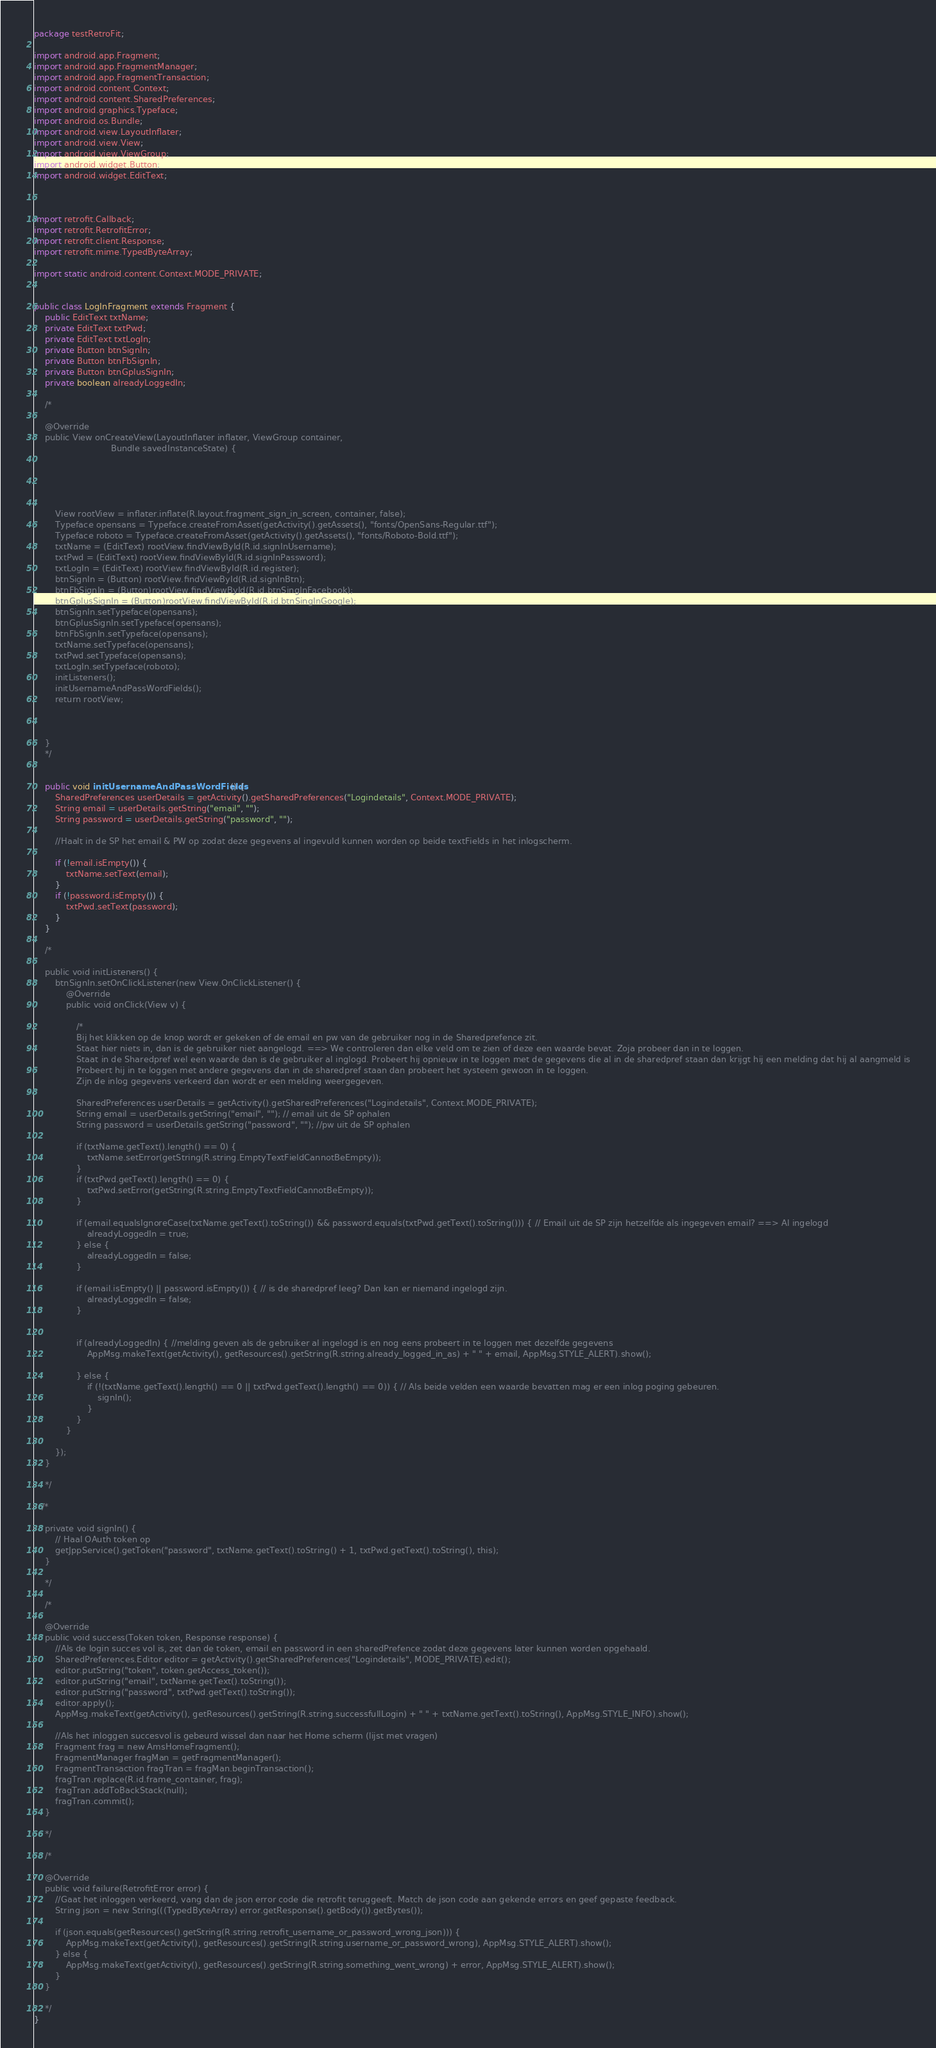<code> <loc_0><loc_0><loc_500><loc_500><_Java_>package testRetroFit;

import android.app.Fragment;
import android.app.FragmentManager;
import android.app.FragmentTransaction;
import android.content.Context;
import android.content.SharedPreferences;
import android.graphics.Typeface;
import android.os.Bundle;
import android.view.LayoutInflater;
import android.view.View;
import android.view.ViewGroup;
import android.widget.Button;
import android.widget.EditText;



import retrofit.Callback;
import retrofit.RetrofitError;
import retrofit.client.Response;
import retrofit.mime.TypedByteArray;

import static android.content.Context.MODE_PRIVATE;


public class LogInFragment extends Fragment {
    public EditText txtName;
    private EditText txtPwd;
    private EditText txtLogIn;
    private Button btnSignIn;
    private Button btnFbSignIn;
    private Button btnGplusSignIn;
    private boolean alreadyLoggedIn;

    /*

    @Override
    public View onCreateView(LayoutInflater inflater, ViewGroup container,
                             Bundle savedInstanceState) {





        View rootView = inflater.inflate(R.layout.fragment_sign_in_screen, container, false);
        Typeface opensans = Typeface.createFromAsset(getActivity().getAssets(), "fonts/OpenSans-Regular.ttf");
        Typeface roboto = Typeface.createFromAsset(getActivity().getAssets(), "fonts/Roboto-Bold.ttf");
        txtName = (EditText) rootView.findViewById(R.id.signInUsername);
        txtPwd = (EditText) rootView.findViewById(R.id.signInPassword);
        txtLogIn = (EditText) rootView.findViewById(R.id.register);
        btnSignIn = (Button) rootView.findViewById(R.id.signInBtn);
        btnFbSignIn = (Button)rootView.findViewById(R.id.btnSingInFacebook);
        btnGplusSignIn = (Button)rootView.findViewById(R.id.btnSingInGoogle);
        btnSignIn.setTypeface(opensans);
        btnGplusSignIn.setTypeface(opensans);
        btnFbSignIn.setTypeface(opensans);
        txtName.setTypeface(opensans);
        txtPwd.setTypeface(opensans);
        txtLogIn.setTypeface(roboto);
        initListeners();
        initUsernameAndPassWordFields();
        return rootView;



    }
    */


    public void initUsernameAndPassWordFields() {
        SharedPreferences userDetails = getActivity().getSharedPreferences("Logindetails", Context.MODE_PRIVATE);
        String email = userDetails.getString("email", "");
        String password = userDetails.getString("password", "");

        //Haalt in de SP het email & PW op zodat deze gegevens al ingevuld kunnen worden op beide textFields in het inlogscherm.

        if (!email.isEmpty()) {
            txtName.setText(email);
        }
        if (!password.isEmpty()) {
            txtPwd.setText(password);
        }
    }

    /*

    public void initListeners() {
        btnSignIn.setOnClickListener(new View.OnClickListener() {
            @Override
            public void onClick(View v) {

                /*
                Bij het klikken op de knop wordt er gekeken of de email en pw van de gebruiker nog in de Sharedprefence zit.
                Staat hier niets in, dan is de gebruiker niet aangelogd. ==> We controleren dan elke veld om te zien of deze een waarde bevat. Zoja probeer dan in te loggen.
                Staat in de Sharedpref wel een waarde dan is de gebruiker al inglogd. Probeert hij opnieuw in te loggen met de gegevens die al in de sharedpref staan dan krijgt hij een melding dat hij al aangmeld is
                Probeert hij in te loggen met andere gegevens dan in de sharedpref staan dan probeert het systeem gewoon in te loggen.
                Zijn de inlog gegevens verkeerd dan wordt er een melding weergegeven.

                SharedPreferences userDetails = getActivity().getSharedPreferences("Logindetails", Context.MODE_PRIVATE);
                String email = userDetails.getString("email", ""); // email uit de SP ophalen
                String password = userDetails.getString("password", ""); //pw uit de SP ophalen

                if (txtName.getText().length() == 0) {
                    txtName.setError(getString(R.string.EmptyTextFieldCannotBeEmpty));
                }
                if (txtPwd.getText().length() == 0) {
                    txtPwd.setError(getString(R.string.EmptyTextFieldCannotBeEmpty));
                }

                if (email.equalsIgnoreCase(txtName.getText().toString()) && password.equals(txtPwd.getText().toString())) { // Email uit de SP zijn hetzelfde als ingegeven email? ==> Al ingelogd
                    alreadyLoggedIn = true;
                } else {
                    alreadyLoggedIn = false;
                }

                if (email.isEmpty() || password.isEmpty()) { // is de sharedpref leeg? Dan kan er niemand ingelogd zijn.
                    alreadyLoggedIn = false;
                }


                if (alreadyLoggedIn) { //melding geven als de gebruiker al ingelogd is en nog eens probeert in te loggen met dezelfde gegevens
                    AppMsg.makeText(getActivity(), getResources().getString(R.string.already_logged_in_as) + " " + email, AppMsg.STYLE_ALERT).show();

                } else {
                    if (!(txtName.getText().length() == 0 || txtPwd.getText().length() == 0)) { // Als beide velden een waarde bevatten mag er een inlog poging gebeuren.
                        signIn();
                    }
                }
            }

        });
    }

    */

   /*

    private void signIn() {
        // Haal OAuth token op
        getJppService().getToken("password", txtName.getText().toString() + 1, txtPwd.getText().toString(), this);
    }

    */

    /*

    @Override
    public void success(Token token, Response response) {
        //Als de login succes vol is, zet dan de token, email en password in een sharedPrefence zodat deze gegevens later kunnen worden opgehaald.
        SharedPreferences.Editor editor = getActivity().getSharedPreferences("Logindetails", MODE_PRIVATE).edit();
        editor.putString("token", token.getAccess_token());
        editor.putString("email", txtName.getText().toString());
        editor.putString("password", txtPwd.getText().toString());
        editor.apply();
        AppMsg.makeText(getActivity(), getResources().getString(R.string.successfullLogin) + " " + txtName.getText().toString(), AppMsg.STYLE_INFO).show();

        //Als het inloggen succesvol is gebeurd wissel dan naar het Home scherm (lijst met vragen)
        Fragment frag = new AmsHomeFragment();
        FragmentManager fragMan = getFragmentManager();
        FragmentTransaction fragTran = fragMan.beginTransaction();
        fragTran.replace(R.id.frame_container, frag);
        fragTran.addToBackStack(null);
        fragTran.commit();
    }

    */

    /*

    @Override
    public void failure(RetrofitError error) {
        //Gaat het inloggen verkeerd, vang dan de json error code die retrofit teruggeeft. Match de json code aan gekende errors en geef gepaste feedback.
        String json = new String(((TypedByteArray) error.getResponse().getBody()).getBytes());

        if (json.equals(getResources().getString(R.string.retrofit_username_or_password_wrong_json))) {
            AppMsg.makeText(getActivity(), getResources().getString(R.string.username_or_password_wrong), AppMsg.STYLE_ALERT).show();
        } else {
            AppMsg.makeText(getActivity(), getResources().getString(R.string.something_went_wrong) + error, AppMsg.STYLE_ALERT).show();
        }
    }

    */
}
</code> 